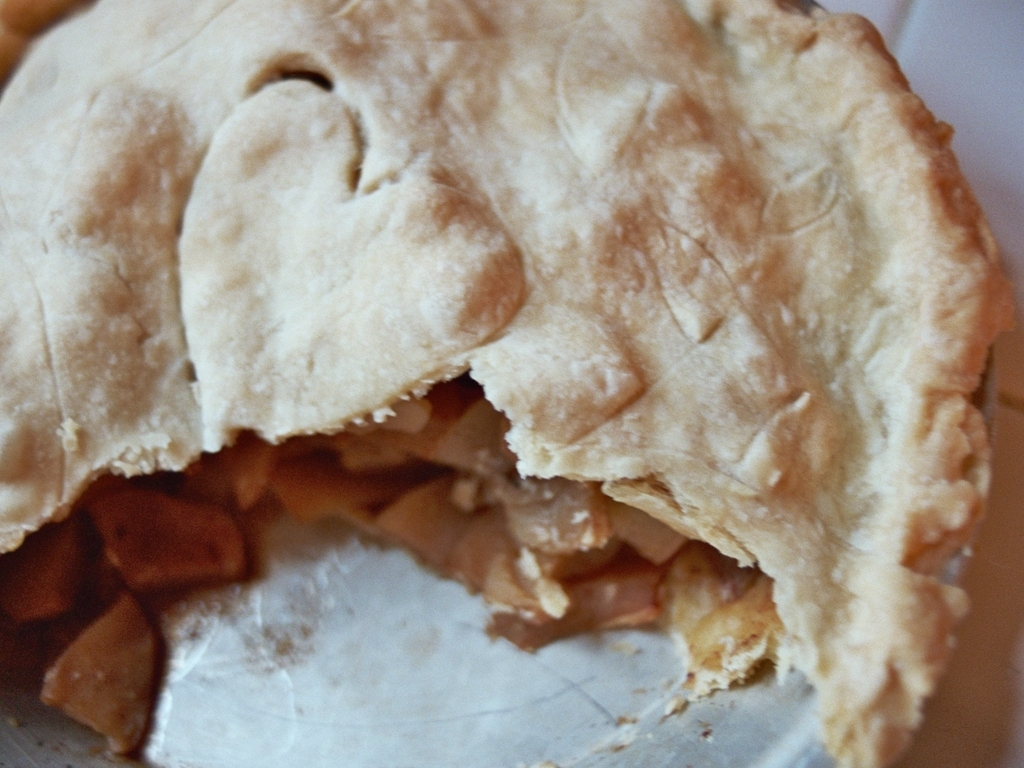Are there any other quality issues in this image?
A. Yes
B. No
Answer with the option's letter from the given choices directly.
 B. 